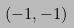Convert formula to latex. <formula><loc_0><loc_0><loc_500><loc_500>( - 1 , - 1 )</formula> 